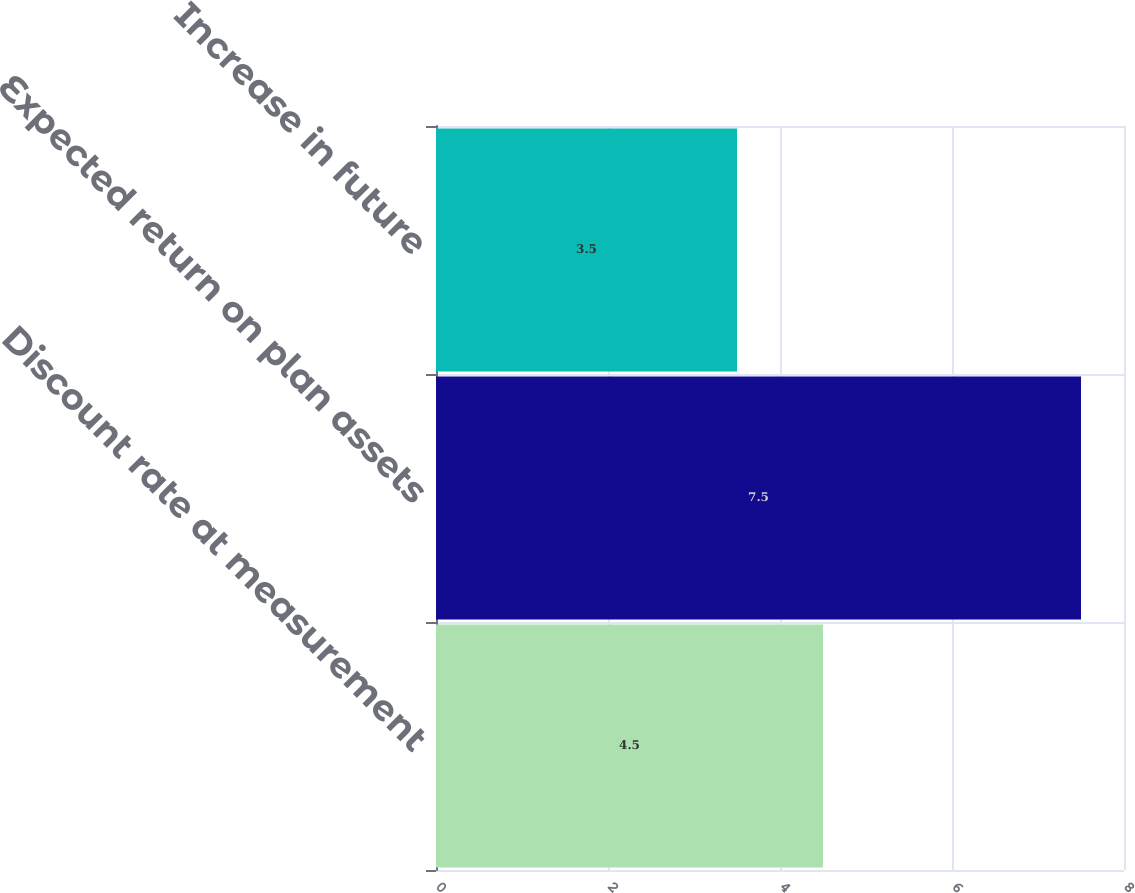Convert chart to OTSL. <chart><loc_0><loc_0><loc_500><loc_500><bar_chart><fcel>Discount rate at measurement<fcel>Expected return on plan assets<fcel>Increase in future<nl><fcel>4.5<fcel>7.5<fcel>3.5<nl></chart> 